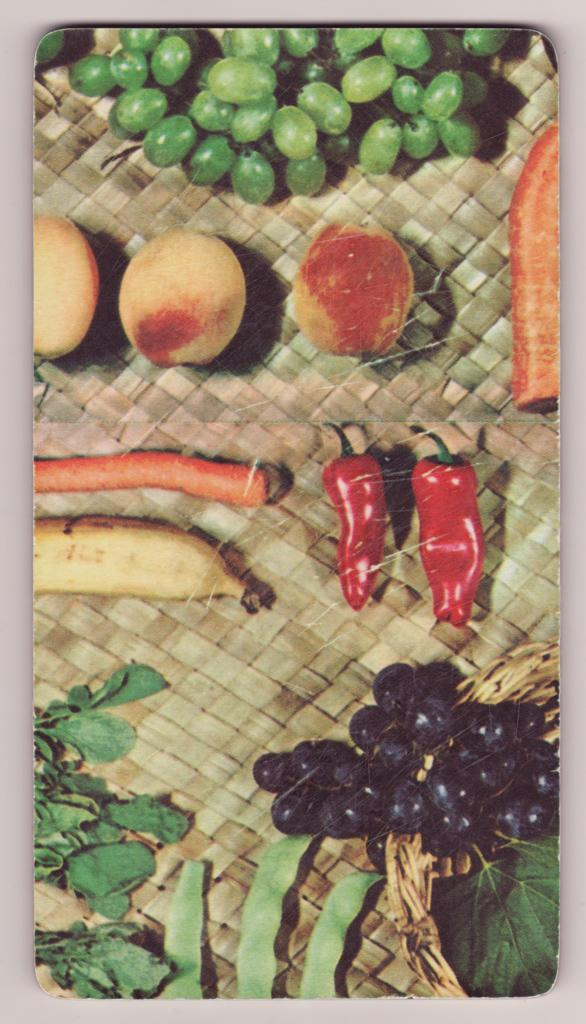What is the main object on the table in the image? There is a cutting mat on the table in the image. What is the purpose of the cutting mat? The cutting mat is used for cutting or preparing food items. What types of food items can be seen on the cutting mat? There are fruits and vegetables on the cutting mat. Can you see any bees buzzing around the fruits on the cutting mat? There are no bees present in the image; it only shows fruits and vegetables on the cutting mat. How many chairs are visible around the table in the image? The image does not show any chairs; it only shows a cutting mat on a table with fruits and vegetables. 